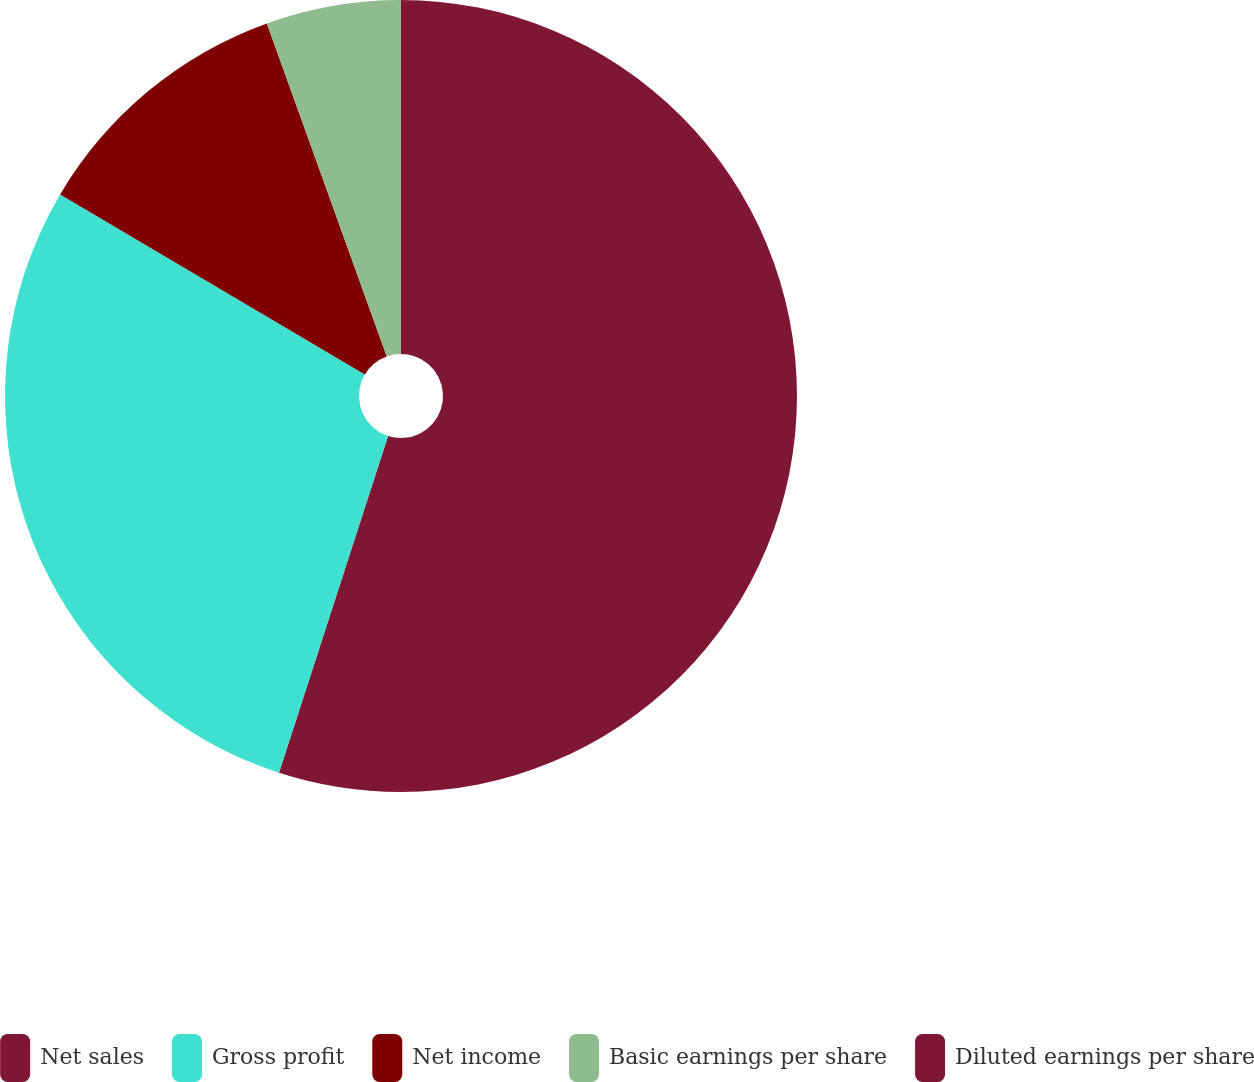Convert chart to OTSL. <chart><loc_0><loc_0><loc_500><loc_500><pie_chart><fcel>Net sales<fcel>Gross profit<fcel>Net income<fcel>Basic earnings per share<fcel>Diluted earnings per share<nl><fcel>54.99%<fcel>28.52%<fcel>11.0%<fcel>5.5%<fcel>0.0%<nl></chart> 